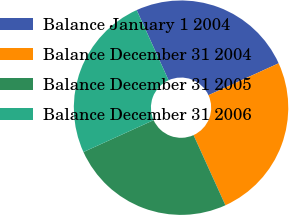Convert chart to OTSL. <chart><loc_0><loc_0><loc_500><loc_500><pie_chart><fcel>Balance January 1 2004<fcel>Balance December 31 2004<fcel>Balance December 31 2005<fcel>Balance December 31 2006<nl><fcel>25.0%<fcel>25.0%<fcel>25.0%<fcel>25.0%<nl></chart> 